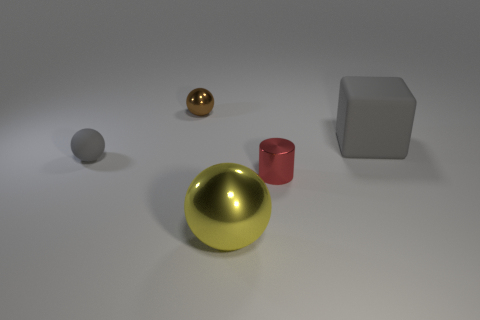Add 4 small purple blocks. How many objects exist? 9 Subtract all balls. How many objects are left? 2 Subtract all big gray rubber cubes. Subtract all yellow metallic spheres. How many objects are left? 3 Add 3 tiny cylinders. How many tiny cylinders are left? 4 Add 3 big brown metal balls. How many big brown metal balls exist? 3 Subtract 0 green cubes. How many objects are left? 5 